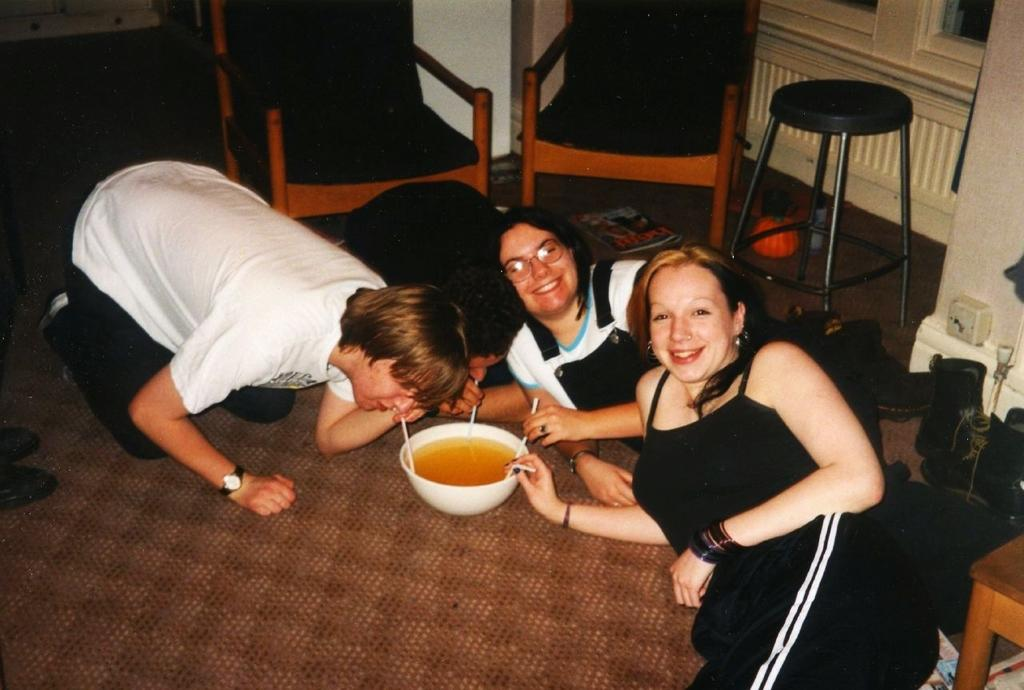How many people are in the image? There are two women and a man in the image. What object can be seen in the image besides the people? There is a bowl in the image. What type of furniture is visible in the background of the image? There are two chairs and a stool in the background of the image. What type of toe is visible on the man's foot in the image? There is no toe visible on the man's foot in the image, as the image does not show any feet or toes. 